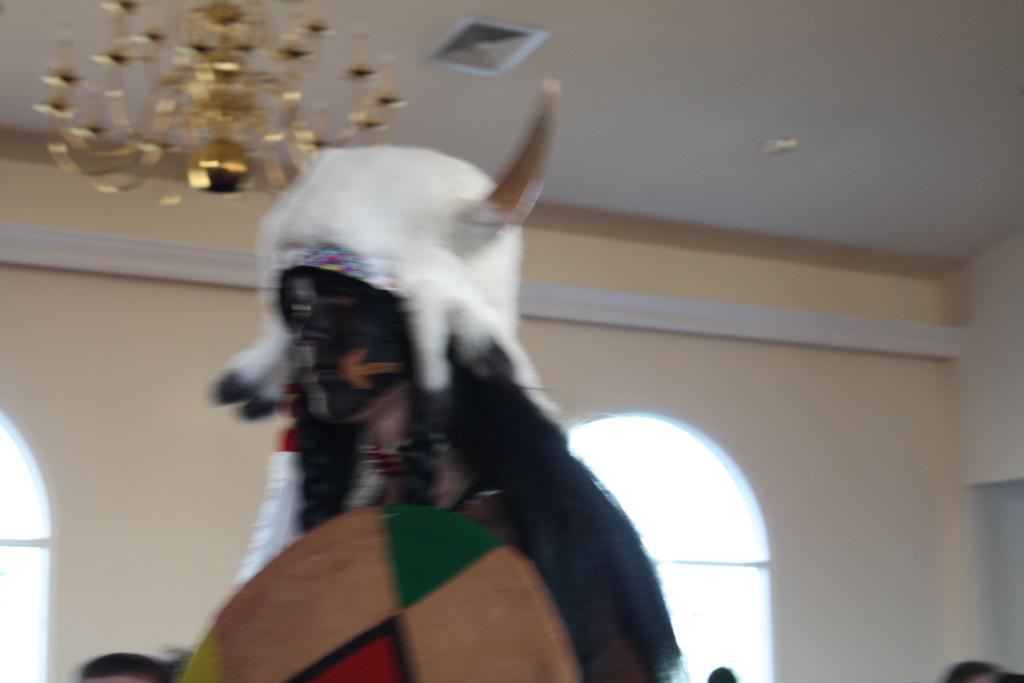Please provide a concise description of this image. This is a blur image. Here I can see a person wearing costume, cap on the head and holding an object. At the bottom, I can see few people. In the background there is a wall along with the windows. At the top of the image there is a chandelier. 